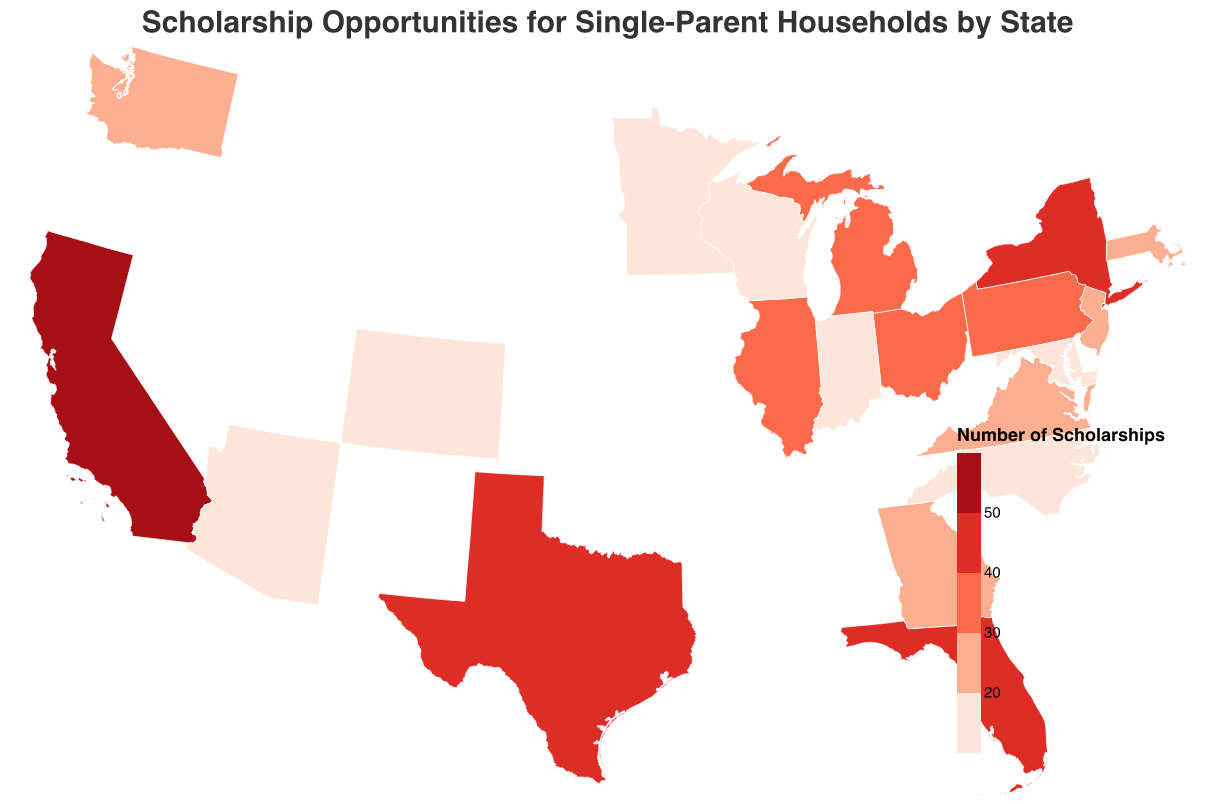What is the title of the figure? The title is displayed at the top of the figure, in larger and distinct font size and style. By looking at the top of the figure, we can read the title.
Answer: Scholarship Opportunities for Single-Parent Households by State How many scholarships are there in Texas? To answer this question, look at the tooltip or legend associated with Texas in the geographic plot.
Answer: 45 Which state has the highest average award amount? Check the tooltips for each state and compare the "Average Award ($)" values. The highest figure will indicate the state with the highest average award amount.
Answer: California Compare the number of scholarships between Ohio and Illinois. Which state has more? Locate Ohio and Illinois on the geographic plot, and compare their "Number of Scholarships" values. Ohio has 32, and Illinois has 38. Therefore, Illinois has more scholarships.
Answer: Illinois What is the average number of scholarships for the given states? To find the average number, sum all the scholarship counts for each state and divide it by the number of states (20 states). Calculated as (52+48+45+40+38+35+32+30+28+25+23+22+20+18+17+15+14+13+12+11) / 20 = 28.35
Answer: 28.35 Which states have an average award amount greater than $4800? Check the tooltips for each state, and list the states where the "Average Award ($)" is greater than 4800. These states are California (5500), New York (5200), Massachusetts (5100), and New Jersey (5000).
Answer: California, New York, Massachusetts, New Jersey How many states have more than 30 scholarships available? Check the scholarship count for each state in the plot and count the number of states with a "Number of Scholarships" greater than 30. These states are California, New York, Texas, Florida, Illinois, and Pennsylvania, totaling 6 states.
Answer: 6 What is the total number of scholarships available across all states? Sum the "Number of Scholarships" for all the states. Calculated as 52+48+45+40+38+35+32+30+28+25+23+22+20+18+17+15+14+13+12+11 = 528
Answer: 528 Which state offers the lowest average award amount, and what is that amount? Check the tooltips for each state, and find the state with the lowest "Average Award ($)". Indiana has the lowest average award amount of $4100.
Answer: Indiana, 4100 